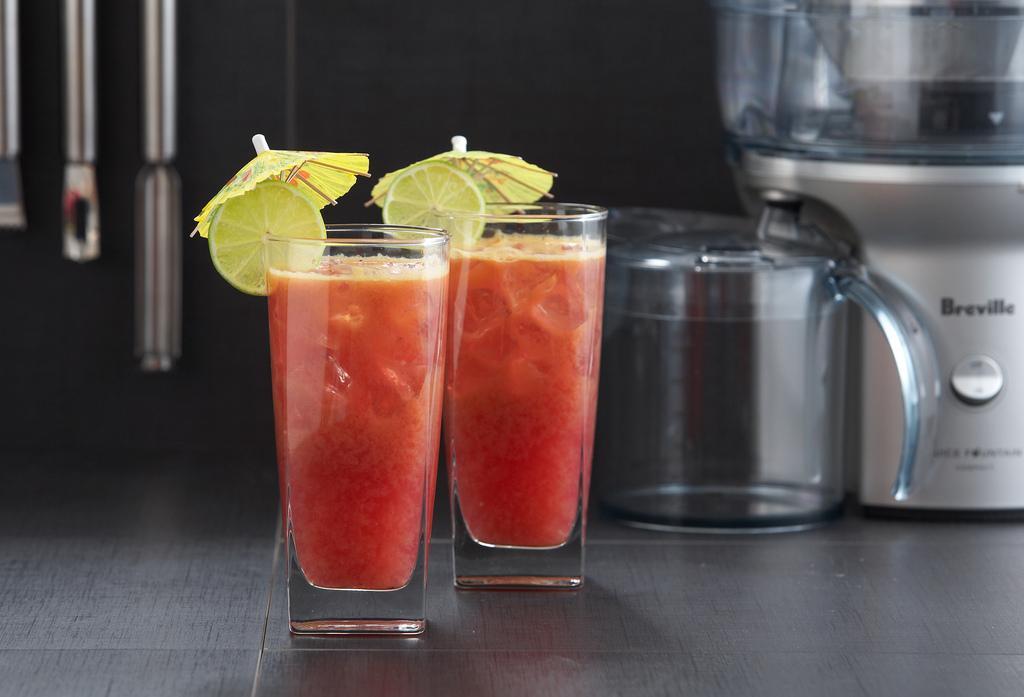How would you summarize this image in a sentence or two? In this image I can see the black colored surface and on the black colored surface I can see 2 glasses with orange colors liquid in them and 2 lemon pieces and small umbrellas on the glass. In the background I can see few other equipments and utensils. 